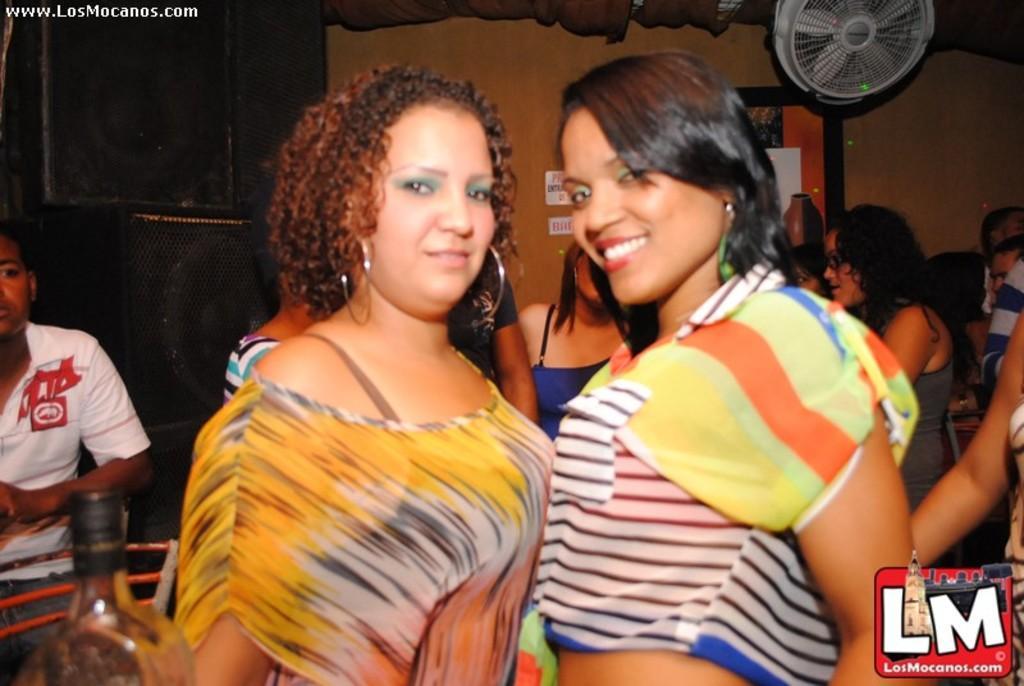How would you summarize this image in a sentence or two? In this image we can see a group of people standing on the floor. On the left side of the image we can see a bottle, group of speakers and a chair. In the background of the image we can see a photo frame on the wall and a board with some text. At the top of the image we can see curtain and a fan. In the top left corner of the image we can see some text. 